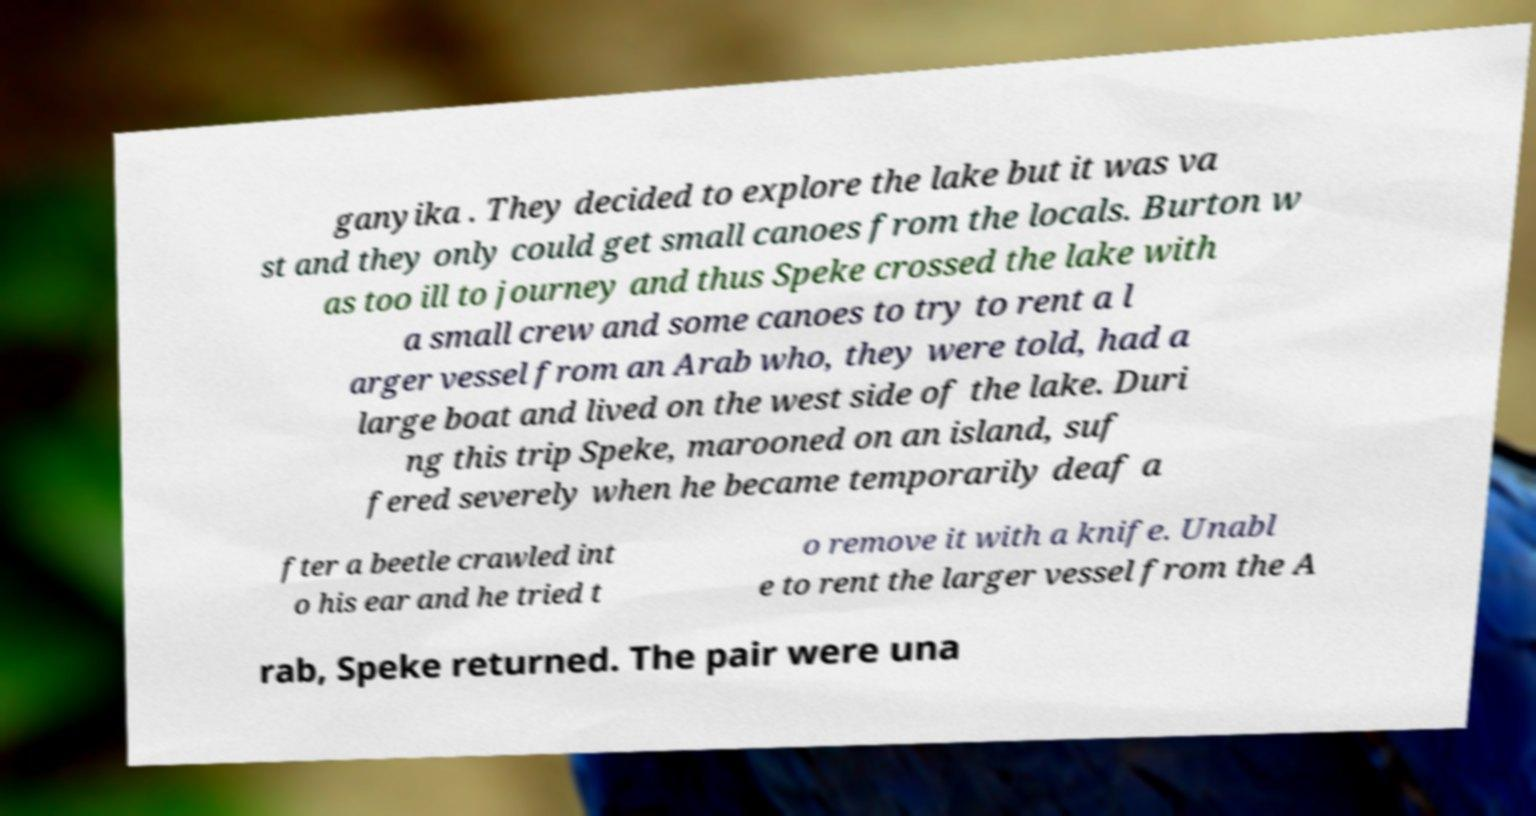I need the written content from this picture converted into text. Can you do that? ganyika . They decided to explore the lake but it was va st and they only could get small canoes from the locals. Burton w as too ill to journey and thus Speke crossed the lake with a small crew and some canoes to try to rent a l arger vessel from an Arab who, they were told, had a large boat and lived on the west side of the lake. Duri ng this trip Speke, marooned on an island, suf fered severely when he became temporarily deaf a fter a beetle crawled int o his ear and he tried t o remove it with a knife. Unabl e to rent the larger vessel from the A rab, Speke returned. The pair were una 